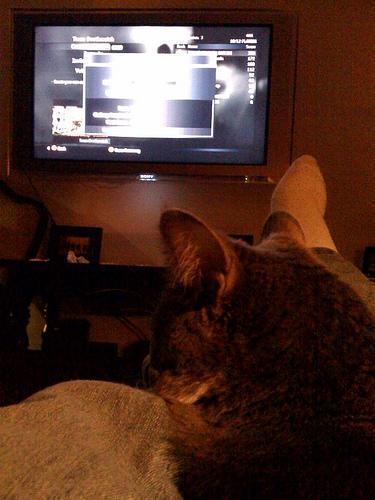What is the person doing in the bed?
Answer the question by selecting the correct answer among the 4 following choices and explain your choice with a short sentence. The answer should be formatted with the following format: `Answer: choice
Rationale: rationale.`
Options: Cleaning, sleeping, watching television, eating. Answer: watching television.
Rationale: The television is on and judging by the angle of the picture and where the foot is, the person is looking at the television. 